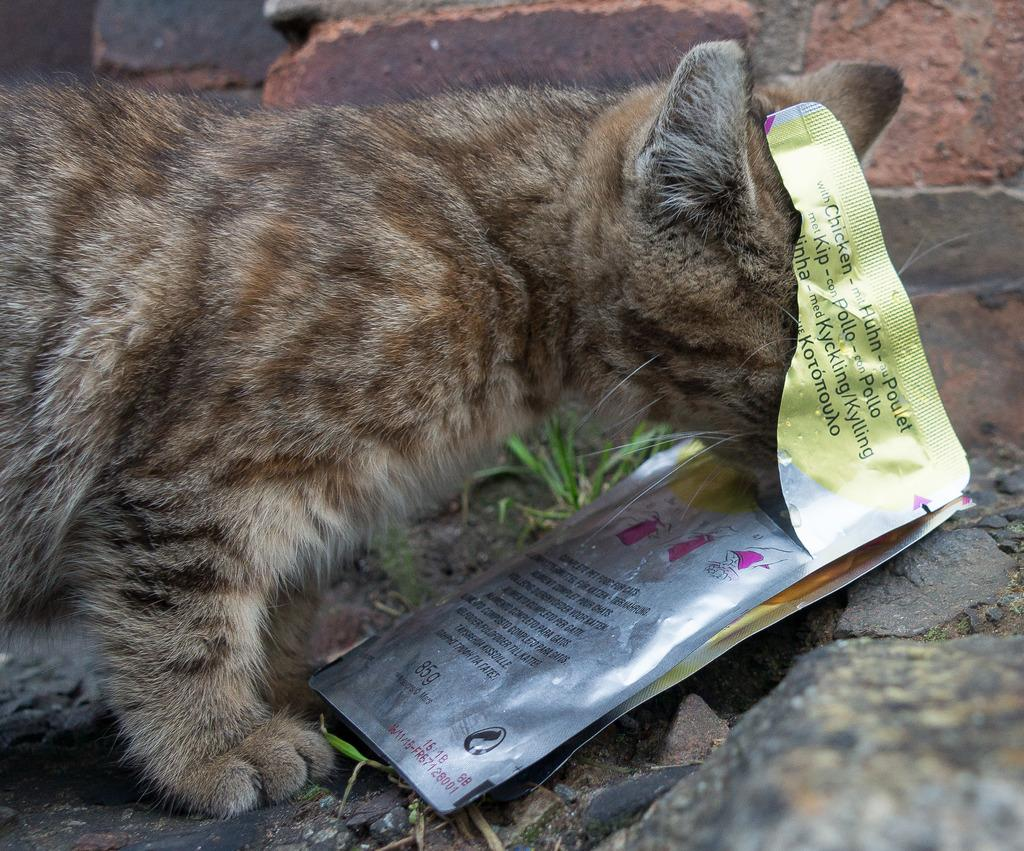What type of animal can be seen in the image? There is a cat in the image. What is located on the right side of the image? There is a packet on the right side of the image. What can be seen in the background of the image? There is a brick wall and grass visible in the background of the image. What year is depicted on the curtain in the image? There is no curtain present in the image, so it is not possible to determine the year depicted on it. 